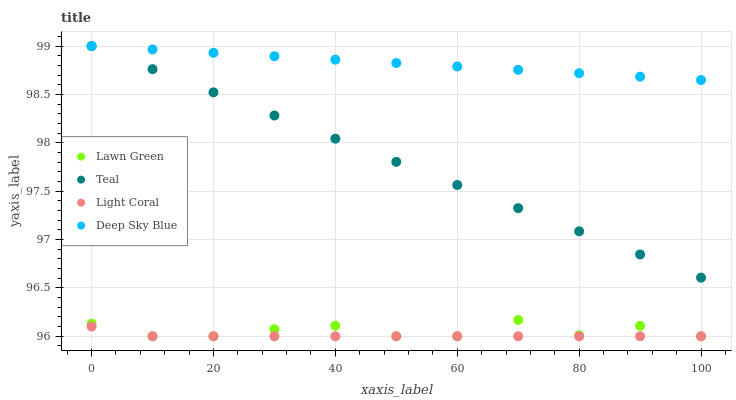Does Light Coral have the minimum area under the curve?
Answer yes or no. Yes. Does Deep Sky Blue have the maximum area under the curve?
Answer yes or no. Yes. Does Lawn Green have the minimum area under the curve?
Answer yes or no. No. Does Lawn Green have the maximum area under the curve?
Answer yes or no. No. Is Deep Sky Blue the smoothest?
Answer yes or no. Yes. Is Lawn Green the roughest?
Answer yes or no. Yes. Is Lawn Green the smoothest?
Answer yes or no. No. Is Deep Sky Blue the roughest?
Answer yes or no. No. Does Light Coral have the lowest value?
Answer yes or no. Yes. Does Deep Sky Blue have the lowest value?
Answer yes or no. No. Does Teal have the highest value?
Answer yes or no. Yes. Does Lawn Green have the highest value?
Answer yes or no. No. Is Light Coral less than Deep Sky Blue?
Answer yes or no. Yes. Is Deep Sky Blue greater than Lawn Green?
Answer yes or no. Yes. Does Deep Sky Blue intersect Teal?
Answer yes or no. Yes. Is Deep Sky Blue less than Teal?
Answer yes or no. No. Is Deep Sky Blue greater than Teal?
Answer yes or no. No. Does Light Coral intersect Deep Sky Blue?
Answer yes or no. No. 